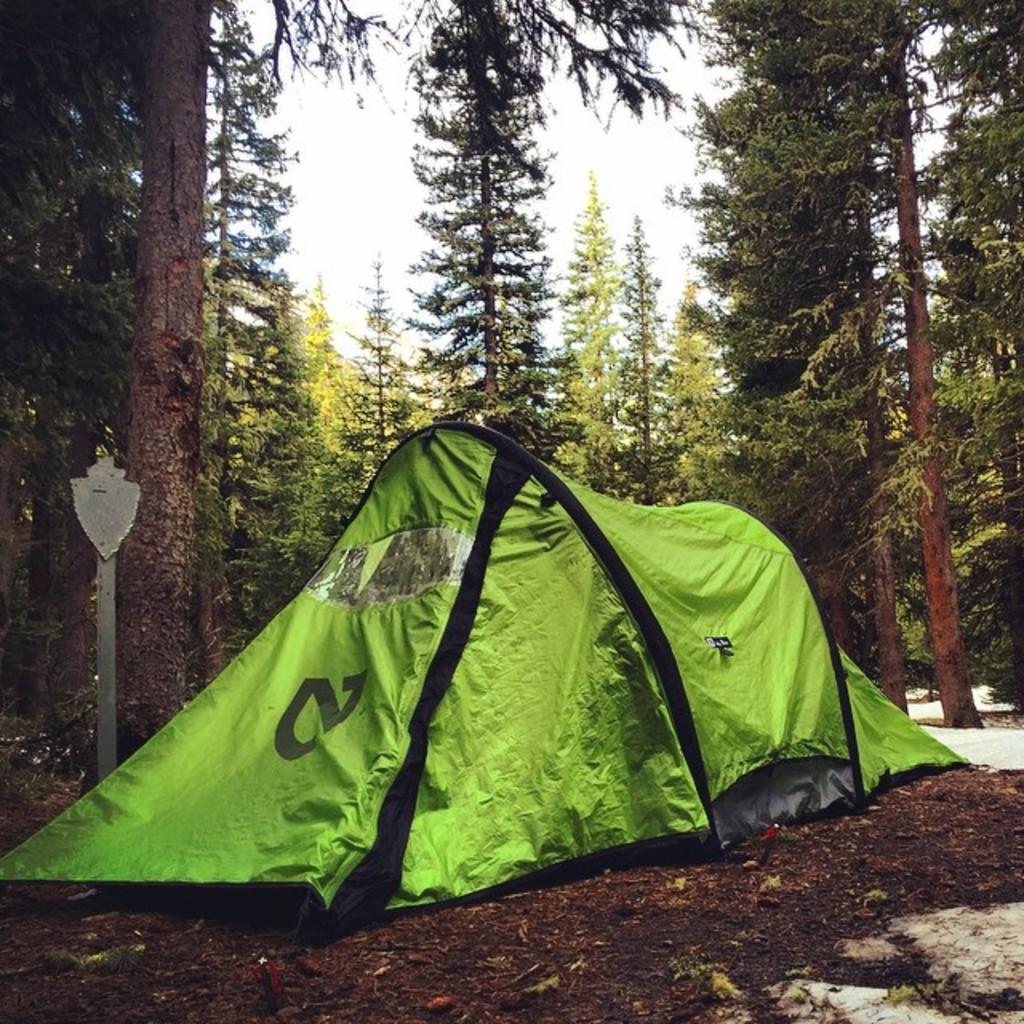In one or two sentences, can you explain what this image depicts? In the image there is a hiking tent on the ground and around that tent there are many tall trees. 